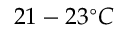<formula> <loc_0><loc_0><loc_500><loc_500>2 1 - 2 3 ^ { \circ } C</formula> 